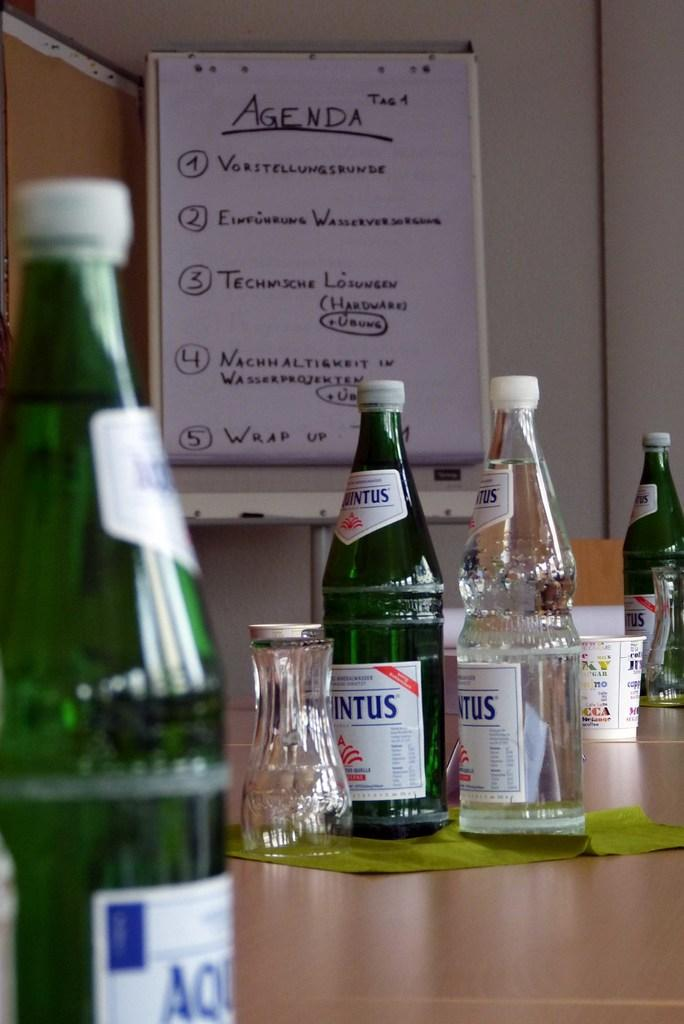<image>
Summarize the visual content of the image. A white board has a list that is titled agenda. 